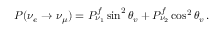Convert formula to latex. <formula><loc_0><loc_0><loc_500><loc_500>P ( \nu _ { e } \rightarrow \nu _ { \mu } ) = P _ { \nu _ { 1 } } ^ { f } \sin ^ { 2 } \theta _ { v } + P _ { \nu _ { 2 } } ^ { f } \cos ^ { 2 } \theta _ { v } \, .</formula> 